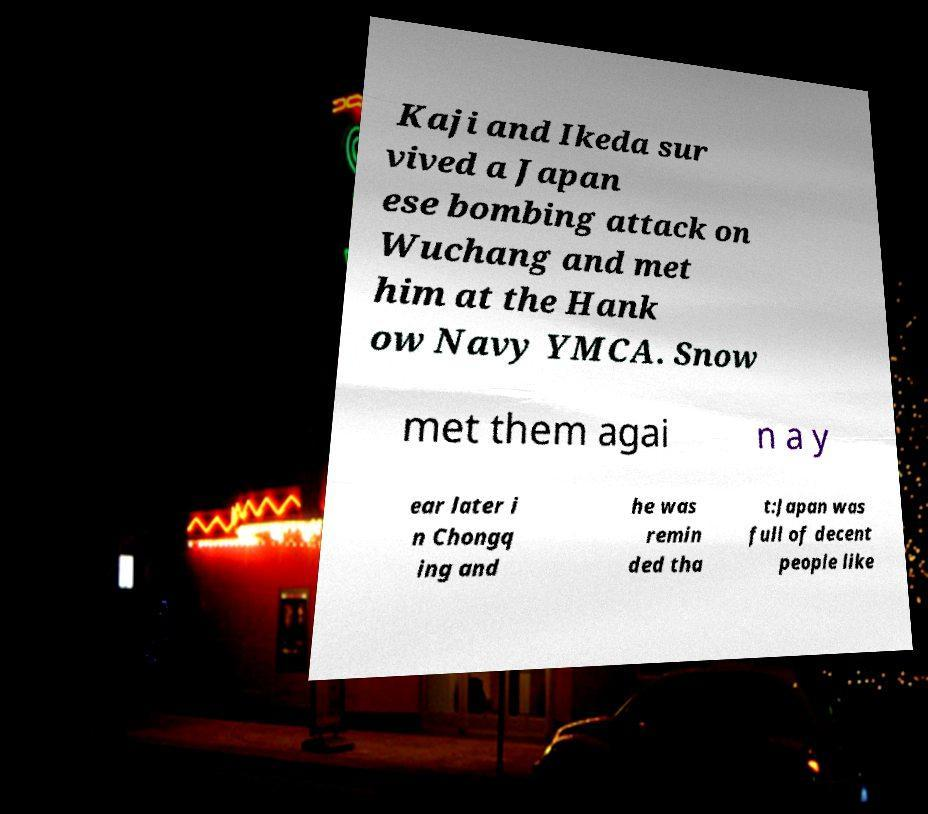Could you assist in decoding the text presented in this image and type it out clearly? Kaji and Ikeda sur vived a Japan ese bombing attack on Wuchang and met him at the Hank ow Navy YMCA. Snow met them agai n a y ear later i n Chongq ing and he was remin ded tha t:Japan was full of decent people like 